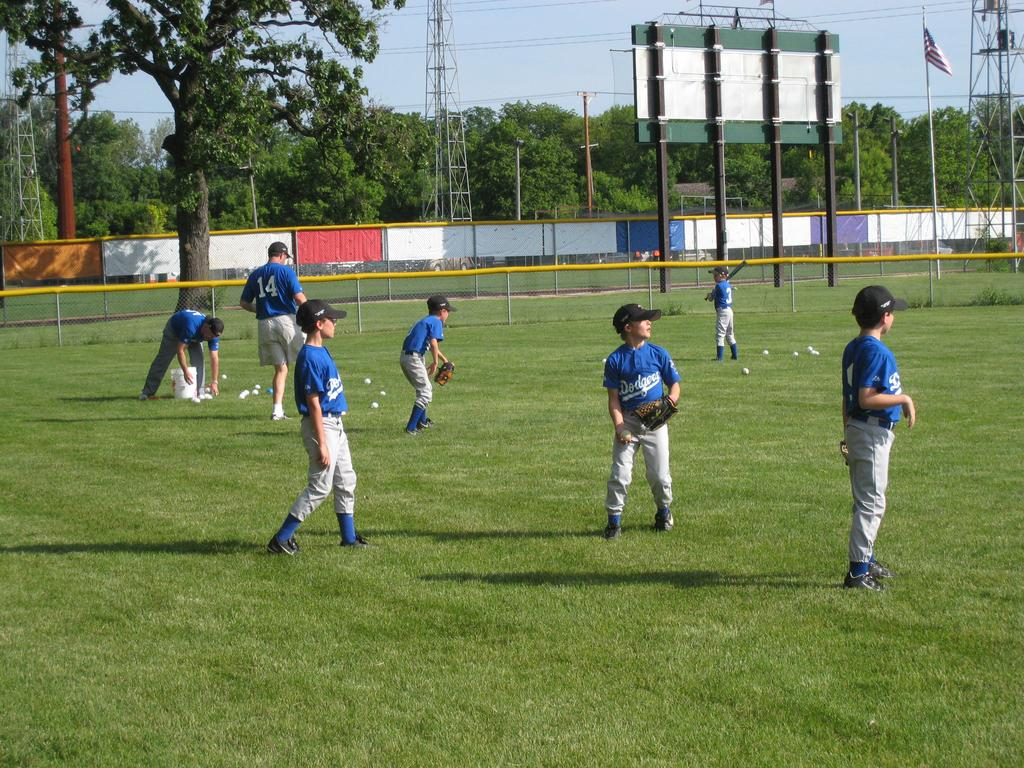<image>
Share a concise interpretation of the image provided. the team name Dodgers that is on a shirt 